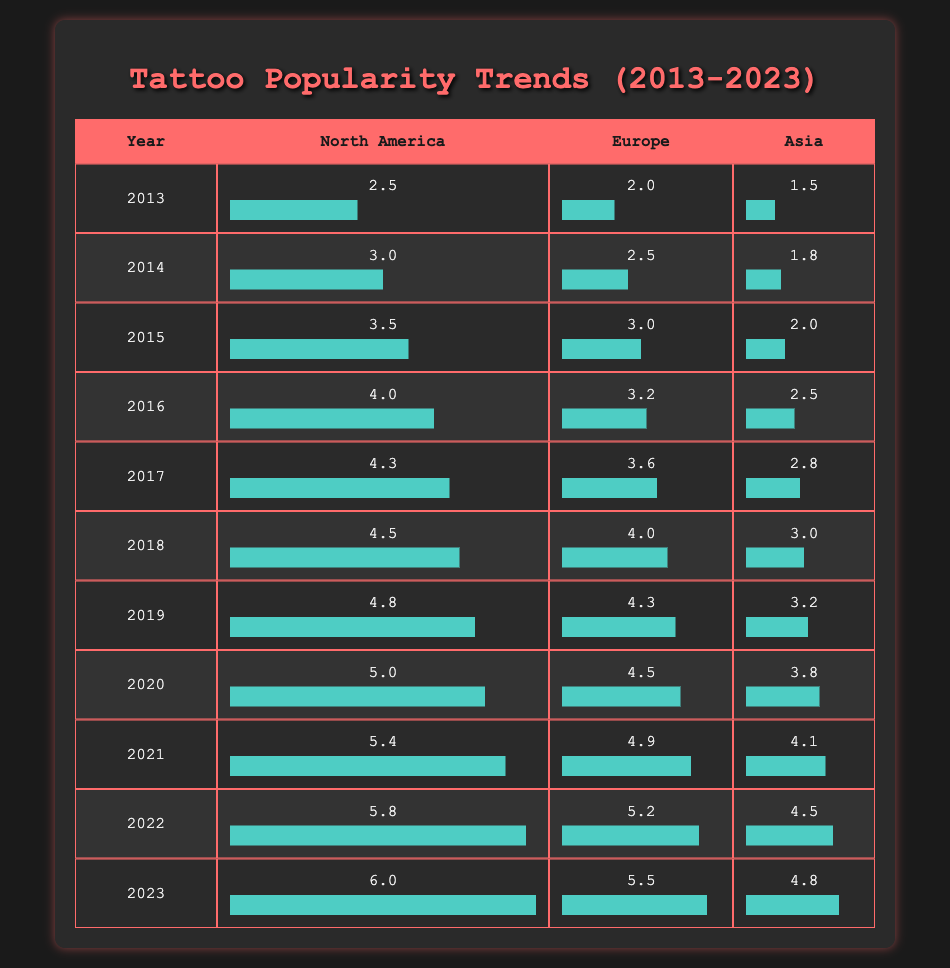What was the popularity index of tattoos in North America in 2015? Looking at the table, I find the row for the year 2015 under North America. It shows a popularity index of 3.5.
Answer: 3.5 Which region had the highest popularity index in 2023? In the row for 2023, North America has a popularity index of 6.0, which is higher than Europe (5.5) and Asia (4.8).
Answer: North America What is the average popularity index of tattoos in Europe over the last decade (2013-2023)? To calculate the average, I total the values for Europe from 2013 to 2023: (2.0 + 2.5 + 3.0 + 3.2 + 3.6 + 4.0 + 4.3 + 4.5 + 4.9 + 5.2 + 5.5) = 43.7. Then divide by 11 (number of years), which results in approximately 3.98.
Answer: 3.98 Was there a year in which the popularity index for Asia was lower than 2.0? Looking at the table for Asia, the lowest value is 1.5 in 2013, which is lower than 2.0.
Answer: Yes What was the percentage increase in the popularity index for North America from 2013 to 2023? The popularity index in 2013 was 2.5 and in 2023 it was 6.0. The increase is 6.0 - 2.5 = 3.5. The percentage increase is (3.5 / 2.5) * 100 = 140%.
Answer: 140% In which year did Europe first exceed a popularity index of 4.0? By checking the row entries, Europe reached a popularity index of 4.0 in 2018 and increased to 4.3 in 2019. Thus, 2018 is the first year it exceeded 4.0.
Answer: 2018 Which region had the steepest increase in popularity from 2020 to 2023? For North America, the increase from 5.0 to 6.0 is 1.0. In Europe, it increased from 4.5 to 5.5, a change of 1.0. In Asia, the change was from 3.8 to 4.8, an increase of 1.0. Since all three regions had the same increase of 1.0, there’s no single region with a steepest increase.
Answer: All had equal increase of 1.0 What was Asia's popularity index in 2019, and how does it compare to the index in 2022? In 2019, Asia's popularity index was 3.2, and in 2022 it was 4.5. To compare, 4.5 is greater than 3.2, indicating an increase.
Answer: 3.2 in 2019; increased to 4.5 in 2022 